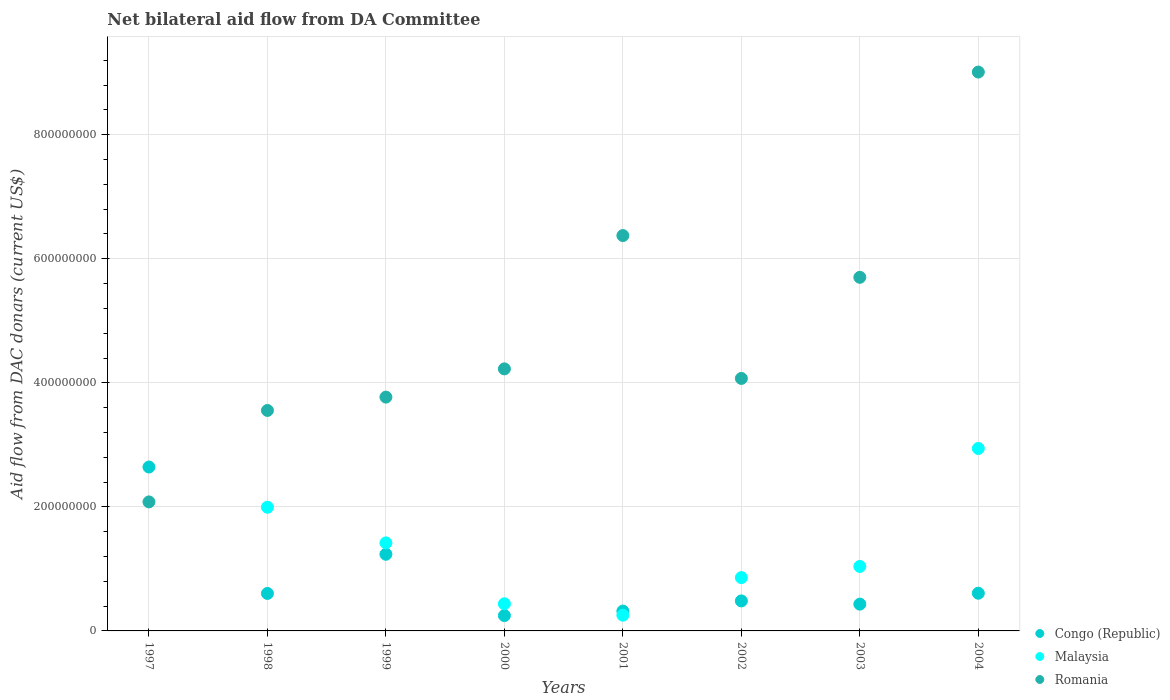How many different coloured dotlines are there?
Keep it short and to the point. 3. What is the aid flow in in Romania in 1998?
Keep it short and to the point. 3.55e+08. Across all years, what is the maximum aid flow in in Romania?
Provide a short and direct response. 9.01e+08. Across all years, what is the minimum aid flow in in Romania?
Provide a short and direct response. 2.08e+08. In which year was the aid flow in in Congo (Republic) maximum?
Make the answer very short. 1997. What is the total aid flow in in Congo (Republic) in the graph?
Offer a terse response. 6.57e+08. What is the difference between the aid flow in in Congo (Republic) in 2001 and that in 2003?
Keep it short and to the point. -1.12e+07. What is the difference between the aid flow in in Malaysia in 2002 and the aid flow in in Romania in 2003?
Your answer should be compact. -4.84e+08. What is the average aid flow in in Congo (Republic) per year?
Provide a succinct answer. 8.22e+07. In the year 2002, what is the difference between the aid flow in in Congo (Republic) and aid flow in in Romania?
Your response must be concise. -3.59e+08. What is the ratio of the aid flow in in Congo (Republic) in 1999 to that in 2003?
Make the answer very short. 2.86. Is the aid flow in in Romania in 2000 less than that in 2001?
Your answer should be very brief. Yes. What is the difference between the highest and the second highest aid flow in in Malaysia?
Your response must be concise. 9.47e+07. What is the difference between the highest and the lowest aid flow in in Malaysia?
Provide a succinct answer. 2.94e+08. In how many years, is the aid flow in in Malaysia greater than the average aid flow in in Malaysia taken over all years?
Your answer should be very brief. 3. Does the aid flow in in Malaysia monotonically increase over the years?
Your response must be concise. No. Is the aid flow in in Malaysia strictly greater than the aid flow in in Romania over the years?
Your answer should be compact. No. How many dotlines are there?
Provide a succinct answer. 3. What is the difference between two consecutive major ticks on the Y-axis?
Offer a very short reply. 2.00e+08. What is the title of the graph?
Offer a very short reply. Net bilateral aid flow from DA Committee. What is the label or title of the X-axis?
Your answer should be very brief. Years. What is the label or title of the Y-axis?
Provide a succinct answer. Aid flow from DAC donars (current US$). What is the Aid flow from DAC donars (current US$) in Congo (Republic) in 1997?
Your response must be concise. 2.64e+08. What is the Aid flow from DAC donars (current US$) of Romania in 1997?
Provide a short and direct response. 2.08e+08. What is the Aid flow from DAC donars (current US$) of Congo (Republic) in 1998?
Give a very brief answer. 6.04e+07. What is the Aid flow from DAC donars (current US$) in Malaysia in 1998?
Your answer should be very brief. 1.99e+08. What is the Aid flow from DAC donars (current US$) of Romania in 1998?
Your answer should be compact. 3.55e+08. What is the Aid flow from DAC donars (current US$) of Congo (Republic) in 1999?
Keep it short and to the point. 1.24e+08. What is the Aid flow from DAC donars (current US$) of Malaysia in 1999?
Your answer should be very brief. 1.42e+08. What is the Aid flow from DAC donars (current US$) in Romania in 1999?
Your answer should be compact. 3.77e+08. What is the Aid flow from DAC donars (current US$) in Congo (Republic) in 2000?
Give a very brief answer. 2.48e+07. What is the Aid flow from DAC donars (current US$) of Malaysia in 2000?
Give a very brief answer. 4.37e+07. What is the Aid flow from DAC donars (current US$) of Romania in 2000?
Your answer should be compact. 4.22e+08. What is the Aid flow from DAC donars (current US$) of Congo (Republic) in 2001?
Keep it short and to the point. 3.20e+07. What is the Aid flow from DAC donars (current US$) in Malaysia in 2001?
Provide a succinct answer. 2.54e+07. What is the Aid flow from DAC donars (current US$) of Romania in 2001?
Give a very brief answer. 6.37e+08. What is the Aid flow from DAC donars (current US$) in Congo (Republic) in 2002?
Your response must be concise. 4.84e+07. What is the Aid flow from DAC donars (current US$) of Malaysia in 2002?
Offer a very short reply. 8.60e+07. What is the Aid flow from DAC donars (current US$) in Romania in 2002?
Provide a short and direct response. 4.07e+08. What is the Aid flow from DAC donars (current US$) of Congo (Republic) in 2003?
Provide a short and direct response. 4.32e+07. What is the Aid flow from DAC donars (current US$) in Malaysia in 2003?
Provide a short and direct response. 1.04e+08. What is the Aid flow from DAC donars (current US$) of Romania in 2003?
Keep it short and to the point. 5.70e+08. What is the Aid flow from DAC donars (current US$) in Congo (Republic) in 2004?
Your answer should be compact. 6.08e+07. What is the Aid flow from DAC donars (current US$) of Malaysia in 2004?
Give a very brief answer. 2.94e+08. What is the Aid flow from DAC donars (current US$) of Romania in 2004?
Keep it short and to the point. 9.01e+08. Across all years, what is the maximum Aid flow from DAC donars (current US$) of Congo (Republic)?
Your answer should be compact. 2.64e+08. Across all years, what is the maximum Aid flow from DAC donars (current US$) of Malaysia?
Your answer should be very brief. 2.94e+08. Across all years, what is the maximum Aid flow from DAC donars (current US$) in Romania?
Ensure brevity in your answer.  9.01e+08. Across all years, what is the minimum Aid flow from DAC donars (current US$) of Congo (Republic)?
Provide a succinct answer. 2.48e+07. Across all years, what is the minimum Aid flow from DAC donars (current US$) in Romania?
Your response must be concise. 2.08e+08. What is the total Aid flow from DAC donars (current US$) of Congo (Republic) in the graph?
Your answer should be compact. 6.57e+08. What is the total Aid flow from DAC donars (current US$) of Malaysia in the graph?
Give a very brief answer. 8.95e+08. What is the total Aid flow from DAC donars (current US$) of Romania in the graph?
Ensure brevity in your answer.  3.88e+09. What is the difference between the Aid flow from DAC donars (current US$) of Congo (Republic) in 1997 and that in 1998?
Keep it short and to the point. 2.04e+08. What is the difference between the Aid flow from DAC donars (current US$) in Romania in 1997 and that in 1998?
Make the answer very short. -1.47e+08. What is the difference between the Aid flow from DAC donars (current US$) of Congo (Republic) in 1997 and that in 1999?
Keep it short and to the point. 1.41e+08. What is the difference between the Aid flow from DAC donars (current US$) in Romania in 1997 and that in 1999?
Provide a succinct answer. -1.69e+08. What is the difference between the Aid flow from DAC donars (current US$) of Congo (Republic) in 1997 and that in 2000?
Your answer should be very brief. 2.39e+08. What is the difference between the Aid flow from DAC donars (current US$) in Romania in 1997 and that in 2000?
Keep it short and to the point. -2.14e+08. What is the difference between the Aid flow from DAC donars (current US$) in Congo (Republic) in 1997 and that in 2001?
Provide a succinct answer. 2.32e+08. What is the difference between the Aid flow from DAC donars (current US$) of Romania in 1997 and that in 2001?
Provide a succinct answer. -4.29e+08. What is the difference between the Aid flow from DAC donars (current US$) of Congo (Republic) in 1997 and that in 2002?
Offer a very short reply. 2.16e+08. What is the difference between the Aid flow from DAC donars (current US$) in Romania in 1997 and that in 2002?
Provide a short and direct response. -1.99e+08. What is the difference between the Aid flow from DAC donars (current US$) of Congo (Republic) in 1997 and that in 2003?
Provide a succinct answer. 2.21e+08. What is the difference between the Aid flow from DAC donars (current US$) in Romania in 1997 and that in 2003?
Provide a succinct answer. -3.62e+08. What is the difference between the Aid flow from DAC donars (current US$) in Congo (Republic) in 1997 and that in 2004?
Your answer should be compact. 2.03e+08. What is the difference between the Aid flow from DAC donars (current US$) in Romania in 1997 and that in 2004?
Make the answer very short. -6.93e+08. What is the difference between the Aid flow from DAC donars (current US$) of Congo (Republic) in 1998 and that in 1999?
Your response must be concise. -6.32e+07. What is the difference between the Aid flow from DAC donars (current US$) in Malaysia in 1998 and that in 1999?
Provide a short and direct response. 5.75e+07. What is the difference between the Aid flow from DAC donars (current US$) in Romania in 1998 and that in 1999?
Keep it short and to the point. -2.15e+07. What is the difference between the Aid flow from DAC donars (current US$) of Congo (Republic) in 1998 and that in 2000?
Provide a short and direct response. 3.56e+07. What is the difference between the Aid flow from DAC donars (current US$) in Malaysia in 1998 and that in 2000?
Keep it short and to the point. 1.56e+08. What is the difference between the Aid flow from DAC donars (current US$) of Romania in 1998 and that in 2000?
Offer a terse response. -6.70e+07. What is the difference between the Aid flow from DAC donars (current US$) of Congo (Republic) in 1998 and that in 2001?
Give a very brief answer. 2.84e+07. What is the difference between the Aid flow from DAC donars (current US$) of Malaysia in 1998 and that in 2001?
Provide a succinct answer. 1.74e+08. What is the difference between the Aid flow from DAC donars (current US$) of Romania in 1998 and that in 2001?
Your response must be concise. -2.82e+08. What is the difference between the Aid flow from DAC donars (current US$) in Congo (Republic) in 1998 and that in 2002?
Provide a succinct answer. 1.21e+07. What is the difference between the Aid flow from DAC donars (current US$) in Malaysia in 1998 and that in 2002?
Your answer should be very brief. 1.13e+08. What is the difference between the Aid flow from DAC donars (current US$) of Romania in 1998 and that in 2002?
Provide a short and direct response. -5.16e+07. What is the difference between the Aid flow from DAC donars (current US$) in Congo (Republic) in 1998 and that in 2003?
Your answer should be compact. 1.72e+07. What is the difference between the Aid flow from DAC donars (current US$) of Malaysia in 1998 and that in 2003?
Provide a succinct answer. 9.55e+07. What is the difference between the Aid flow from DAC donars (current US$) of Romania in 1998 and that in 2003?
Your answer should be compact. -2.15e+08. What is the difference between the Aid flow from DAC donars (current US$) in Congo (Republic) in 1998 and that in 2004?
Ensure brevity in your answer.  -3.70e+05. What is the difference between the Aid flow from DAC donars (current US$) in Malaysia in 1998 and that in 2004?
Your answer should be very brief. -9.47e+07. What is the difference between the Aid flow from DAC donars (current US$) of Romania in 1998 and that in 2004?
Your response must be concise. -5.46e+08. What is the difference between the Aid flow from DAC donars (current US$) of Congo (Republic) in 1999 and that in 2000?
Your response must be concise. 9.88e+07. What is the difference between the Aid flow from DAC donars (current US$) of Malaysia in 1999 and that in 2000?
Provide a succinct answer. 9.82e+07. What is the difference between the Aid flow from DAC donars (current US$) of Romania in 1999 and that in 2000?
Provide a succinct answer. -4.55e+07. What is the difference between the Aid flow from DAC donars (current US$) in Congo (Republic) in 1999 and that in 2001?
Keep it short and to the point. 9.16e+07. What is the difference between the Aid flow from DAC donars (current US$) in Malaysia in 1999 and that in 2001?
Give a very brief answer. 1.17e+08. What is the difference between the Aid flow from DAC donars (current US$) of Romania in 1999 and that in 2001?
Ensure brevity in your answer.  -2.60e+08. What is the difference between the Aid flow from DAC donars (current US$) in Congo (Republic) in 1999 and that in 2002?
Your answer should be compact. 7.52e+07. What is the difference between the Aid flow from DAC donars (current US$) of Malaysia in 1999 and that in 2002?
Your response must be concise. 5.59e+07. What is the difference between the Aid flow from DAC donars (current US$) in Romania in 1999 and that in 2002?
Offer a very short reply. -3.01e+07. What is the difference between the Aid flow from DAC donars (current US$) of Congo (Republic) in 1999 and that in 2003?
Your answer should be compact. 8.04e+07. What is the difference between the Aid flow from DAC donars (current US$) of Malaysia in 1999 and that in 2003?
Make the answer very short. 3.79e+07. What is the difference between the Aid flow from DAC donars (current US$) of Romania in 1999 and that in 2003?
Make the answer very short. -1.93e+08. What is the difference between the Aid flow from DAC donars (current US$) in Congo (Republic) in 1999 and that in 2004?
Your answer should be compact. 6.28e+07. What is the difference between the Aid flow from DAC donars (current US$) in Malaysia in 1999 and that in 2004?
Offer a very short reply. -1.52e+08. What is the difference between the Aid flow from DAC donars (current US$) of Romania in 1999 and that in 2004?
Provide a short and direct response. -5.24e+08. What is the difference between the Aid flow from DAC donars (current US$) of Congo (Republic) in 2000 and that in 2001?
Provide a short and direct response. -7.24e+06. What is the difference between the Aid flow from DAC donars (current US$) in Malaysia in 2000 and that in 2001?
Offer a terse response. 1.84e+07. What is the difference between the Aid flow from DAC donars (current US$) in Romania in 2000 and that in 2001?
Ensure brevity in your answer.  -2.15e+08. What is the difference between the Aid flow from DAC donars (current US$) of Congo (Republic) in 2000 and that in 2002?
Your response must be concise. -2.36e+07. What is the difference between the Aid flow from DAC donars (current US$) of Malaysia in 2000 and that in 2002?
Keep it short and to the point. -4.22e+07. What is the difference between the Aid flow from DAC donars (current US$) of Romania in 2000 and that in 2002?
Provide a short and direct response. 1.54e+07. What is the difference between the Aid flow from DAC donars (current US$) of Congo (Republic) in 2000 and that in 2003?
Your answer should be compact. -1.84e+07. What is the difference between the Aid flow from DAC donars (current US$) of Malaysia in 2000 and that in 2003?
Make the answer very short. -6.02e+07. What is the difference between the Aid flow from DAC donars (current US$) of Romania in 2000 and that in 2003?
Provide a short and direct response. -1.48e+08. What is the difference between the Aid flow from DAC donars (current US$) of Congo (Republic) in 2000 and that in 2004?
Provide a short and direct response. -3.60e+07. What is the difference between the Aid flow from DAC donars (current US$) in Malaysia in 2000 and that in 2004?
Offer a terse response. -2.50e+08. What is the difference between the Aid flow from DAC donars (current US$) of Romania in 2000 and that in 2004?
Ensure brevity in your answer.  -4.79e+08. What is the difference between the Aid flow from DAC donars (current US$) of Congo (Republic) in 2001 and that in 2002?
Your answer should be compact. -1.64e+07. What is the difference between the Aid flow from DAC donars (current US$) in Malaysia in 2001 and that in 2002?
Your answer should be compact. -6.06e+07. What is the difference between the Aid flow from DAC donars (current US$) in Romania in 2001 and that in 2002?
Ensure brevity in your answer.  2.30e+08. What is the difference between the Aid flow from DAC donars (current US$) of Congo (Republic) in 2001 and that in 2003?
Keep it short and to the point. -1.12e+07. What is the difference between the Aid flow from DAC donars (current US$) of Malaysia in 2001 and that in 2003?
Keep it short and to the point. -7.86e+07. What is the difference between the Aid flow from DAC donars (current US$) of Romania in 2001 and that in 2003?
Provide a short and direct response. 6.73e+07. What is the difference between the Aid flow from DAC donars (current US$) of Congo (Republic) in 2001 and that in 2004?
Your response must be concise. -2.88e+07. What is the difference between the Aid flow from DAC donars (current US$) of Malaysia in 2001 and that in 2004?
Give a very brief answer. -2.69e+08. What is the difference between the Aid flow from DAC donars (current US$) of Romania in 2001 and that in 2004?
Offer a terse response. -2.64e+08. What is the difference between the Aid flow from DAC donars (current US$) in Congo (Republic) in 2002 and that in 2003?
Your answer should be very brief. 5.19e+06. What is the difference between the Aid flow from DAC donars (current US$) in Malaysia in 2002 and that in 2003?
Offer a terse response. -1.80e+07. What is the difference between the Aid flow from DAC donars (current US$) of Romania in 2002 and that in 2003?
Offer a very short reply. -1.63e+08. What is the difference between the Aid flow from DAC donars (current US$) in Congo (Republic) in 2002 and that in 2004?
Your response must be concise. -1.24e+07. What is the difference between the Aid flow from DAC donars (current US$) in Malaysia in 2002 and that in 2004?
Provide a succinct answer. -2.08e+08. What is the difference between the Aid flow from DAC donars (current US$) in Romania in 2002 and that in 2004?
Give a very brief answer. -4.94e+08. What is the difference between the Aid flow from DAC donars (current US$) in Congo (Republic) in 2003 and that in 2004?
Your answer should be very brief. -1.76e+07. What is the difference between the Aid flow from DAC donars (current US$) in Malaysia in 2003 and that in 2004?
Your response must be concise. -1.90e+08. What is the difference between the Aid flow from DAC donars (current US$) in Romania in 2003 and that in 2004?
Give a very brief answer. -3.31e+08. What is the difference between the Aid flow from DAC donars (current US$) in Congo (Republic) in 1997 and the Aid flow from DAC donars (current US$) in Malaysia in 1998?
Make the answer very short. 6.48e+07. What is the difference between the Aid flow from DAC donars (current US$) of Congo (Republic) in 1997 and the Aid flow from DAC donars (current US$) of Romania in 1998?
Keep it short and to the point. -9.12e+07. What is the difference between the Aid flow from DAC donars (current US$) in Congo (Republic) in 1997 and the Aid flow from DAC donars (current US$) in Malaysia in 1999?
Offer a very short reply. 1.22e+08. What is the difference between the Aid flow from DAC donars (current US$) in Congo (Republic) in 1997 and the Aid flow from DAC donars (current US$) in Romania in 1999?
Provide a succinct answer. -1.13e+08. What is the difference between the Aid flow from DAC donars (current US$) in Congo (Republic) in 1997 and the Aid flow from DAC donars (current US$) in Malaysia in 2000?
Your answer should be very brief. 2.20e+08. What is the difference between the Aid flow from DAC donars (current US$) in Congo (Republic) in 1997 and the Aid flow from DAC donars (current US$) in Romania in 2000?
Your response must be concise. -1.58e+08. What is the difference between the Aid flow from DAC donars (current US$) in Congo (Republic) in 1997 and the Aid flow from DAC donars (current US$) in Malaysia in 2001?
Provide a succinct answer. 2.39e+08. What is the difference between the Aid flow from DAC donars (current US$) of Congo (Republic) in 1997 and the Aid flow from DAC donars (current US$) of Romania in 2001?
Give a very brief answer. -3.73e+08. What is the difference between the Aid flow from DAC donars (current US$) in Congo (Republic) in 1997 and the Aid flow from DAC donars (current US$) in Malaysia in 2002?
Provide a short and direct response. 1.78e+08. What is the difference between the Aid flow from DAC donars (current US$) of Congo (Republic) in 1997 and the Aid flow from DAC donars (current US$) of Romania in 2002?
Keep it short and to the point. -1.43e+08. What is the difference between the Aid flow from DAC donars (current US$) in Congo (Republic) in 1997 and the Aid flow from DAC donars (current US$) in Malaysia in 2003?
Your answer should be very brief. 1.60e+08. What is the difference between the Aid flow from DAC donars (current US$) of Congo (Republic) in 1997 and the Aid flow from DAC donars (current US$) of Romania in 2003?
Provide a succinct answer. -3.06e+08. What is the difference between the Aid flow from DAC donars (current US$) in Congo (Republic) in 1997 and the Aid flow from DAC donars (current US$) in Malaysia in 2004?
Give a very brief answer. -2.99e+07. What is the difference between the Aid flow from DAC donars (current US$) in Congo (Republic) in 1997 and the Aid flow from DAC donars (current US$) in Romania in 2004?
Ensure brevity in your answer.  -6.37e+08. What is the difference between the Aid flow from DAC donars (current US$) in Congo (Republic) in 1998 and the Aid flow from DAC donars (current US$) in Malaysia in 1999?
Your answer should be compact. -8.15e+07. What is the difference between the Aid flow from DAC donars (current US$) of Congo (Republic) in 1998 and the Aid flow from DAC donars (current US$) of Romania in 1999?
Offer a terse response. -3.17e+08. What is the difference between the Aid flow from DAC donars (current US$) of Malaysia in 1998 and the Aid flow from DAC donars (current US$) of Romania in 1999?
Offer a very short reply. -1.78e+08. What is the difference between the Aid flow from DAC donars (current US$) in Congo (Republic) in 1998 and the Aid flow from DAC donars (current US$) in Malaysia in 2000?
Give a very brief answer. 1.67e+07. What is the difference between the Aid flow from DAC donars (current US$) of Congo (Republic) in 1998 and the Aid flow from DAC donars (current US$) of Romania in 2000?
Give a very brief answer. -3.62e+08. What is the difference between the Aid flow from DAC donars (current US$) of Malaysia in 1998 and the Aid flow from DAC donars (current US$) of Romania in 2000?
Offer a terse response. -2.23e+08. What is the difference between the Aid flow from DAC donars (current US$) in Congo (Republic) in 1998 and the Aid flow from DAC donars (current US$) in Malaysia in 2001?
Your response must be concise. 3.50e+07. What is the difference between the Aid flow from DAC donars (current US$) of Congo (Republic) in 1998 and the Aid flow from DAC donars (current US$) of Romania in 2001?
Your response must be concise. -5.77e+08. What is the difference between the Aid flow from DAC donars (current US$) of Malaysia in 1998 and the Aid flow from DAC donars (current US$) of Romania in 2001?
Offer a very short reply. -4.38e+08. What is the difference between the Aid flow from DAC donars (current US$) of Congo (Republic) in 1998 and the Aid flow from DAC donars (current US$) of Malaysia in 2002?
Keep it short and to the point. -2.56e+07. What is the difference between the Aid flow from DAC donars (current US$) in Congo (Republic) in 1998 and the Aid flow from DAC donars (current US$) in Romania in 2002?
Offer a very short reply. -3.47e+08. What is the difference between the Aid flow from DAC donars (current US$) in Malaysia in 1998 and the Aid flow from DAC donars (current US$) in Romania in 2002?
Your answer should be very brief. -2.08e+08. What is the difference between the Aid flow from DAC donars (current US$) of Congo (Republic) in 1998 and the Aid flow from DAC donars (current US$) of Malaysia in 2003?
Ensure brevity in your answer.  -4.36e+07. What is the difference between the Aid flow from DAC donars (current US$) of Congo (Republic) in 1998 and the Aid flow from DAC donars (current US$) of Romania in 2003?
Provide a short and direct response. -5.10e+08. What is the difference between the Aid flow from DAC donars (current US$) in Malaysia in 1998 and the Aid flow from DAC donars (current US$) in Romania in 2003?
Your answer should be very brief. -3.71e+08. What is the difference between the Aid flow from DAC donars (current US$) of Congo (Republic) in 1998 and the Aid flow from DAC donars (current US$) of Malaysia in 2004?
Your answer should be compact. -2.34e+08. What is the difference between the Aid flow from DAC donars (current US$) of Congo (Republic) in 1998 and the Aid flow from DAC donars (current US$) of Romania in 2004?
Make the answer very short. -8.41e+08. What is the difference between the Aid flow from DAC donars (current US$) of Malaysia in 1998 and the Aid flow from DAC donars (current US$) of Romania in 2004?
Ensure brevity in your answer.  -7.02e+08. What is the difference between the Aid flow from DAC donars (current US$) in Congo (Republic) in 1999 and the Aid flow from DAC donars (current US$) in Malaysia in 2000?
Ensure brevity in your answer.  7.98e+07. What is the difference between the Aid flow from DAC donars (current US$) in Congo (Republic) in 1999 and the Aid flow from DAC donars (current US$) in Romania in 2000?
Your answer should be compact. -2.99e+08. What is the difference between the Aid flow from DAC donars (current US$) of Malaysia in 1999 and the Aid flow from DAC donars (current US$) of Romania in 2000?
Offer a terse response. -2.81e+08. What is the difference between the Aid flow from DAC donars (current US$) in Congo (Republic) in 1999 and the Aid flow from DAC donars (current US$) in Malaysia in 2001?
Offer a very short reply. 9.82e+07. What is the difference between the Aid flow from DAC donars (current US$) in Congo (Republic) in 1999 and the Aid flow from DAC donars (current US$) in Romania in 2001?
Keep it short and to the point. -5.14e+08. What is the difference between the Aid flow from DAC donars (current US$) of Malaysia in 1999 and the Aid flow from DAC donars (current US$) of Romania in 2001?
Provide a succinct answer. -4.96e+08. What is the difference between the Aid flow from DAC donars (current US$) in Congo (Republic) in 1999 and the Aid flow from DAC donars (current US$) in Malaysia in 2002?
Provide a short and direct response. 3.76e+07. What is the difference between the Aid flow from DAC donars (current US$) of Congo (Republic) in 1999 and the Aid flow from DAC donars (current US$) of Romania in 2002?
Offer a very short reply. -2.84e+08. What is the difference between the Aid flow from DAC donars (current US$) in Malaysia in 1999 and the Aid flow from DAC donars (current US$) in Romania in 2002?
Offer a very short reply. -2.65e+08. What is the difference between the Aid flow from DAC donars (current US$) in Congo (Republic) in 1999 and the Aid flow from DAC donars (current US$) in Malaysia in 2003?
Provide a succinct answer. 1.96e+07. What is the difference between the Aid flow from DAC donars (current US$) in Congo (Republic) in 1999 and the Aid flow from DAC donars (current US$) in Romania in 2003?
Give a very brief answer. -4.47e+08. What is the difference between the Aid flow from DAC donars (current US$) in Malaysia in 1999 and the Aid flow from DAC donars (current US$) in Romania in 2003?
Give a very brief answer. -4.28e+08. What is the difference between the Aid flow from DAC donars (current US$) of Congo (Republic) in 1999 and the Aid flow from DAC donars (current US$) of Malaysia in 2004?
Your answer should be very brief. -1.71e+08. What is the difference between the Aid flow from DAC donars (current US$) in Congo (Republic) in 1999 and the Aid flow from DAC donars (current US$) in Romania in 2004?
Ensure brevity in your answer.  -7.77e+08. What is the difference between the Aid flow from DAC donars (current US$) of Malaysia in 1999 and the Aid flow from DAC donars (current US$) of Romania in 2004?
Provide a succinct answer. -7.59e+08. What is the difference between the Aid flow from DAC donars (current US$) in Congo (Republic) in 2000 and the Aid flow from DAC donars (current US$) in Malaysia in 2001?
Provide a short and direct response. -6.30e+05. What is the difference between the Aid flow from DAC donars (current US$) of Congo (Republic) in 2000 and the Aid flow from DAC donars (current US$) of Romania in 2001?
Your response must be concise. -6.13e+08. What is the difference between the Aid flow from DAC donars (current US$) of Malaysia in 2000 and the Aid flow from DAC donars (current US$) of Romania in 2001?
Your response must be concise. -5.94e+08. What is the difference between the Aid flow from DAC donars (current US$) of Congo (Republic) in 2000 and the Aid flow from DAC donars (current US$) of Malaysia in 2002?
Ensure brevity in your answer.  -6.12e+07. What is the difference between the Aid flow from DAC donars (current US$) in Congo (Republic) in 2000 and the Aid flow from DAC donars (current US$) in Romania in 2002?
Provide a succinct answer. -3.82e+08. What is the difference between the Aid flow from DAC donars (current US$) in Malaysia in 2000 and the Aid flow from DAC donars (current US$) in Romania in 2002?
Your response must be concise. -3.63e+08. What is the difference between the Aid flow from DAC donars (current US$) of Congo (Republic) in 2000 and the Aid flow from DAC donars (current US$) of Malaysia in 2003?
Your answer should be very brief. -7.92e+07. What is the difference between the Aid flow from DAC donars (current US$) of Congo (Republic) in 2000 and the Aid flow from DAC donars (current US$) of Romania in 2003?
Your answer should be compact. -5.45e+08. What is the difference between the Aid flow from DAC donars (current US$) of Malaysia in 2000 and the Aid flow from DAC donars (current US$) of Romania in 2003?
Your answer should be very brief. -5.26e+08. What is the difference between the Aid flow from DAC donars (current US$) in Congo (Republic) in 2000 and the Aid flow from DAC donars (current US$) in Malaysia in 2004?
Give a very brief answer. -2.69e+08. What is the difference between the Aid flow from DAC donars (current US$) in Congo (Republic) in 2000 and the Aid flow from DAC donars (current US$) in Romania in 2004?
Ensure brevity in your answer.  -8.76e+08. What is the difference between the Aid flow from DAC donars (current US$) in Malaysia in 2000 and the Aid flow from DAC donars (current US$) in Romania in 2004?
Offer a terse response. -8.57e+08. What is the difference between the Aid flow from DAC donars (current US$) in Congo (Republic) in 2001 and the Aid flow from DAC donars (current US$) in Malaysia in 2002?
Your answer should be very brief. -5.40e+07. What is the difference between the Aid flow from DAC donars (current US$) of Congo (Republic) in 2001 and the Aid flow from DAC donars (current US$) of Romania in 2002?
Your response must be concise. -3.75e+08. What is the difference between the Aid flow from DAC donars (current US$) of Malaysia in 2001 and the Aid flow from DAC donars (current US$) of Romania in 2002?
Make the answer very short. -3.82e+08. What is the difference between the Aid flow from DAC donars (current US$) of Congo (Republic) in 2001 and the Aid flow from DAC donars (current US$) of Malaysia in 2003?
Ensure brevity in your answer.  -7.20e+07. What is the difference between the Aid flow from DAC donars (current US$) of Congo (Republic) in 2001 and the Aid flow from DAC donars (current US$) of Romania in 2003?
Keep it short and to the point. -5.38e+08. What is the difference between the Aid flow from DAC donars (current US$) in Malaysia in 2001 and the Aid flow from DAC donars (current US$) in Romania in 2003?
Your response must be concise. -5.45e+08. What is the difference between the Aid flow from DAC donars (current US$) in Congo (Republic) in 2001 and the Aid flow from DAC donars (current US$) in Malaysia in 2004?
Your answer should be compact. -2.62e+08. What is the difference between the Aid flow from DAC donars (current US$) of Congo (Republic) in 2001 and the Aid flow from DAC donars (current US$) of Romania in 2004?
Make the answer very short. -8.69e+08. What is the difference between the Aid flow from DAC donars (current US$) of Malaysia in 2001 and the Aid flow from DAC donars (current US$) of Romania in 2004?
Give a very brief answer. -8.76e+08. What is the difference between the Aid flow from DAC donars (current US$) in Congo (Republic) in 2002 and the Aid flow from DAC donars (current US$) in Malaysia in 2003?
Provide a succinct answer. -5.56e+07. What is the difference between the Aid flow from DAC donars (current US$) of Congo (Republic) in 2002 and the Aid flow from DAC donars (current US$) of Romania in 2003?
Your answer should be compact. -5.22e+08. What is the difference between the Aid flow from DAC donars (current US$) of Malaysia in 2002 and the Aid flow from DAC donars (current US$) of Romania in 2003?
Offer a terse response. -4.84e+08. What is the difference between the Aid flow from DAC donars (current US$) in Congo (Republic) in 2002 and the Aid flow from DAC donars (current US$) in Malaysia in 2004?
Your answer should be very brief. -2.46e+08. What is the difference between the Aid flow from DAC donars (current US$) of Congo (Republic) in 2002 and the Aid flow from DAC donars (current US$) of Romania in 2004?
Ensure brevity in your answer.  -8.53e+08. What is the difference between the Aid flow from DAC donars (current US$) of Malaysia in 2002 and the Aid flow from DAC donars (current US$) of Romania in 2004?
Offer a very short reply. -8.15e+08. What is the difference between the Aid flow from DAC donars (current US$) in Congo (Republic) in 2003 and the Aid flow from DAC donars (current US$) in Malaysia in 2004?
Ensure brevity in your answer.  -2.51e+08. What is the difference between the Aid flow from DAC donars (current US$) of Congo (Republic) in 2003 and the Aid flow from DAC donars (current US$) of Romania in 2004?
Your response must be concise. -8.58e+08. What is the difference between the Aid flow from DAC donars (current US$) of Malaysia in 2003 and the Aid flow from DAC donars (current US$) of Romania in 2004?
Provide a succinct answer. -7.97e+08. What is the average Aid flow from DAC donars (current US$) of Congo (Republic) per year?
Make the answer very short. 8.22e+07. What is the average Aid flow from DAC donars (current US$) in Malaysia per year?
Your response must be concise. 1.12e+08. What is the average Aid flow from DAC donars (current US$) in Romania per year?
Provide a succinct answer. 4.85e+08. In the year 1997, what is the difference between the Aid flow from DAC donars (current US$) of Congo (Republic) and Aid flow from DAC donars (current US$) of Romania?
Make the answer very short. 5.62e+07. In the year 1998, what is the difference between the Aid flow from DAC donars (current US$) of Congo (Republic) and Aid flow from DAC donars (current US$) of Malaysia?
Offer a terse response. -1.39e+08. In the year 1998, what is the difference between the Aid flow from DAC donars (current US$) of Congo (Republic) and Aid flow from DAC donars (current US$) of Romania?
Your answer should be very brief. -2.95e+08. In the year 1998, what is the difference between the Aid flow from DAC donars (current US$) of Malaysia and Aid flow from DAC donars (current US$) of Romania?
Your answer should be compact. -1.56e+08. In the year 1999, what is the difference between the Aid flow from DAC donars (current US$) in Congo (Republic) and Aid flow from DAC donars (current US$) in Malaysia?
Make the answer very short. -1.83e+07. In the year 1999, what is the difference between the Aid flow from DAC donars (current US$) in Congo (Republic) and Aid flow from DAC donars (current US$) in Romania?
Offer a very short reply. -2.53e+08. In the year 1999, what is the difference between the Aid flow from DAC donars (current US$) of Malaysia and Aid flow from DAC donars (current US$) of Romania?
Your response must be concise. -2.35e+08. In the year 2000, what is the difference between the Aid flow from DAC donars (current US$) in Congo (Republic) and Aid flow from DAC donars (current US$) in Malaysia?
Keep it short and to the point. -1.90e+07. In the year 2000, what is the difference between the Aid flow from DAC donars (current US$) of Congo (Republic) and Aid flow from DAC donars (current US$) of Romania?
Make the answer very short. -3.98e+08. In the year 2000, what is the difference between the Aid flow from DAC donars (current US$) in Malaysia and Aid flow from DAC donars (current US$) in Romania?
Ensure brevity in your answer.  -3.79e+08. In the year 2001, what is the difference between the Aid flow from DAC donars (current US$) in Congo (Republic) and Aid flow from DAC donars (current US$) in Malaysia?
Provide a succinct answer. 6.61e+06. In the year 2001, what is the difference between the Aid flow from DAC donars (current US$) of Congo (Republic) and Aid flow from DAC donars (current US$) of Romania?
Offer a very short reply. -6.05e+08. In the year 2001, what is the difference between the Aid flow from DAC donars (current US$) in Malaysia and Aid flow from DAC donars (current US$) in Romania?
Make the answer very short. -6.12e+08. In the year 2002, what is the difference between the Aid flow from DAC donars (current US$) in Congo (Republic) and Aid flow from DAC donars (current US$) in Malaysia?
Keep it short and to the point. -3.76e+07. In the year 2002, what is the difference between the Aid flow from DAC donars (current US$) of Congo (Republic) and Aid flow from DAC donars (current US$) of Romania?
Provide a short and direct response. -3.59e+08. In the year 2002, what is the difference between the Aid flow from DAC donars (current US$) of Malaysia and Aid flow from DAC donars (current US$) of Romania?
Offer a terse response. -3.21e+08. In the year 2003, what is the difference between the Aid flow from DAC donars (current US$) of Congo (Republic) and Aid flow from DAC donars (current US$) of Malaysia?
Ensure brevity in your answer.  -6.08e+07. In the year 2003, what is the difference between the Aid flow from DAC donars (current US$) of Congo (Republic) and Aid flow from DAC donars (current US$) of Romania?
Your response must be concise. -5.27e+08. In the year 2003, what is the difference between the Aid flow from DAC donars (current US$) of Malaysia and Aid flow from DAC donars (current US$) of Romania?
Provide a succinct answer. -4.66e+08. In the year 2004, what is the difference between the Aid flow from DAC donars (current US$) of Congo (Republic) and Aid flow from DAC donars (current US$) of Malaysia?
Give a very brief answer. -2.33e+08. In the year 2004, what is the difference between the Aid flow from DAC donars (current US$) of Congo (Republic) and Aid flow from DAC donars (current US$) of Romania?
Provide a succinct answer. -8.40e+08. In the year 2004, what is the difference between the Aid flow from DAC donars (current US$) of Malaysia and Aid flow from DAC donars (current US$) of Romania?
Your response must be concise. -6.07e+08. What is the ratio of the Aid flow from DAC donars (current US$) of Congo (Republic) in 1997 to that in 1998?
Your answer should be very brief. 4.37. What is the ratio of the Aid flow from DAC donars (current US$) of Romania in 1997 to that in 1998?
Your answer should be compact. 0.59. What is the ratio of the Aid flow from DAC donars (current US$) of Congo (Republic) in 1997 to that in 1999?
Give a very brief answer. 2.14. What is the ratio of the Aid flow from DAC donars (current US$) in Romania in 1997 to that in 1999?
Your answer should be very brief. 0.55. What is the ratio of the Aid flow from DAC donars (current US$) of Congo (Republic) in 1997 to that in 2000?
Offer a very short reply. 10.67. What is the ratio of the Aid flow from DAC donars (current US$) of Romania in 1997 to that in 2000?
Keep it short and to the point. 0.49. What is the ratio of the Aid flow from DAC donars (current US$) in Congo (Republic) in 1997 to that in 2001?
Give a very brief answer. 8.26. What is the ratio of the Aid flow from DAC donars (current US$) of Romania in 1997 to that in 2001?
Give a very brief answer. 0.33. What is the ratio of the Aid flow from DAC donars (current US$) in Congo (Republic) in 1997 to that in 2002?
Your answer should be very brief. 5.47. What is the ratio of the Aid flow from DAC donars (current US$) in Romania in 1997 to that in 2002?
Provide a short and direct response. 0.51. What is the ratio of the Aid flow from DAC donars (current US$) in Congo (Republic) in 1997 to that in 2003?
Your answer should be compact. 6.12. What is the ratio of the Aid flow from DAC donars (current US$) in Romania in 1997 to that in 2003?
Your response must be concise. 0.36. What is the ratio of the Aid flow from DAC donars (current US$) of Congo (Republic) in 1997 to that in 2004?
Offer a terse response. 4.35. What is the ratio of the Aid flow from DAC donars (current US$) of Romania in 1997 to that in 2004?
Make the answer very short. 0.23. What is the ratio of the Aid flow from DAC donars (current US$) of Congo (Republic) in 1998 to that in 1999?
Offer a very short reply. 0.49. What is the ratio of the Aid flow from DAC donars (current US$) in Malaysia in 1998 to that in 1999?
Your response must be concise. 1.41. What is the ratio of the Aid flow from DAC donars (current US$) of Romania in 1998 to that in 1999?
Offer a terse response. 0.94. What is the ratio of the Aid flow from DAC donars (current US$) in Congo (Republic) in 1998 to that in 2000?
Make the answer very short. 2.44. What is the ratio of the Aid flow from DAC donars (current US$) in Malaysia in 1998 to that in 2000?
Provide a short and direct response. 4.56. What is the ratio of the Aid flow from DAC donars (current US$) of Romania in 1998 to that in 2000?
Offer a very short reply. 0.84. What is the ratio of the Aid flow from DAC donars (current US$) in Congo (Republic) in 1998 to that in 2001?
Provide a short and direct response. 1.89. What is the ratio of the Aid flow from DAC donars (current US$) in Malaysia in 1998 to that in 2001?
Give a very brief answer. 7.86. What is the ratio of the Aid flow from DAC donars (current US$) of Romania in 1998 to that in 2001?
Give a very brief answer. 0.56. What is the ratio of the Aid flow from DAC donars (current US$) of Congo (Republic) in 1998 to that in 2002?
Provide a succinct answer. 1.25. What is the ratio of the Aid flow from DAC donars (current US$) of Malaysia in 1998 to that in 2002?
Your answer should be compact. 2.32. What is the ratio of the Aid flow from DAC donars (current US$) in Romania in 1998 to that in 2002?
Offer a very short reply. 0.87. What is the ratio of the Aid flow from DAC donars (current US$) in Congo (Republic) in 1998 to that in 2003?
Make the answer very short. 1.4. What is the ratio of the Aid flow from DAC donars (current US$) of Malaysia in 1998 to that in 2003?
Give a very brief answer. 1.92. What is the ratio of the Aid flow from DAC donars (current US$) in Romania in 1998 to that in 2003?
Give a very brief answer. 0.62. What is the ratio of the Aid flow from DAC donars (current US$) of Malaysia in 1998 to that in 2004?
Your response must be concise. 0.68. What is the ratio of the Aid flow from DAC donars (current US$) of Romania in 1998 to that in 2004?
Offer a terse response. 0.39. What is the ratio of the Aid flow from DAC donars (current US$) in Congo (Republic) in 1999 to that in 2000?
Your answer should be very brief. 4.99. What is the ratio of the Aid flow from DAC donars (current US$) of Malaysia in 1999 to that in 2000?
Your response must be concise. 3.24. What is the ratio of the Aid flow from DAC donars (current US$) of Romania in 1999 to that in 2000?
Give a very brief answer. 0.89. What is the ratio of the Aid flow from DAC donars (current US$) in Congo (Republic) in 1999 to that in 2001?
Your answer should be compact. 3.86. What is the ratio of the Aid flow from DAC donars (current US$) of Malaysia in 1999 to that in 2001?
Keep it short and to the point. 5.59. What is the ratio of the Aid flow from DAC donars (current US$) in Romania in 1999 to that in 2001?
Provide a succinct answer. 0.59. What is the ratio of the Aid flow from DAC donars (current US$) in Congo (Republic) in 1999 to that in 2002?
Provide a short and direct response. 2.56. What is the ratio of the Aid flow from DAC donars (current US$) of Malaysia in 1999 to that in 2002?
Offer a very short reply. 1.65. What is the ratio of the Aid flow from DAC donars (current US$) of Romania in 1999 to that in 2002?
Offer a very short reply. 0.93. What is the ratio of the Aid flow from DAC donars (current US$) of Congo (Republic) in 1999 to that in 2003?
Offer a very short reply. 2.86. What is the ratio of the Aid flow from DAC donars (current US$) of Malaysia in 1999 to that in 2003?
Make the answer very short. 1.36. What is the ratio of the Aid flow from DAC donars (current US$) of Romania in 1999 to that in 2003?
Give a very brief answer. 0.66. What is the ratio of the Aid flow from DAC donars (current US$) in Congo (Republic) in 1999 to that in 2004?
Offer a very short reply. 2.03. What is the ratio of the Aid flow from DAC donars (current US$) of Malaysia in 1999 to that in 2004?
Give a very brief answer. 0.48. What is the ratio of the Aid flow from DAC donars (current US$) in Romania in 1999 to that in 2004?
Ensure brevity in your answer.  0.42. What is the ratio of the Aid flow from DAC donars (current US$) of Congo (Republic) in 2000 to that in 2001?
Your response must be concise. 0.77. What is the ratio of the Aid flow from DAC donars (current US$) of Malaysia in 2000 to that in 2001?
Provide a short and direct response. 1.72. What is the ratio of the Aid flow from DAC donars (current US$) in Romania in 2000 to that in 2001?
Offer a very short reply. 0.66. What is the ratio of the Aid flow from DAC donars (current US$) of Congo (Republic) in 2000 to that in 2002?
Your answer should be compact. 0.51. What is the ratio of the Aid flow from DAC donars (current US$) of Malaysia in 2000 to that in 2002?
Ensure brevity in your answer.  0.51. What is the ratio of the Aid flow from DAC donars (current US$) in Romania in 2000 to that in 2002?
Keep it short and to the point. 1.04. What is the ratio of the Aid flow from DAC donars (current US$) of Congo (Republic) in 2000 to that in 2003?
Make the answer very short. 0.57. What is the ratio of the Aid flow from DAC donars (current US$) in Malaysia in 2000 to that in 2003?
Give a very brief answer. 0.42. What is the ratio of the Aid flow from DAC donars (current US$) of Romania in 2000 to that in 2003?
Keep it short and to the point. 0.74. What is the ratio of the Aid flow from DAC donars (current US$) of Congo (Republic) in 2000 to that in 2004?
Your answer should be very brief. 0.41. What is the ratio of the Aid flow from DAC donars (current US$) of Malaysia in 2000 to that in 2004?
Keep it short and to the point. 0.15. What is the ratio of the Aid flow from DAC donars (current US$) in Romania in 2000 to that in 2004?
Offer a very short reply. 0.47. What is the ratio of the Aid flow from DAC donars (current US$) of Congo (Republic) in 2001 to that in 2002?
Your answer should be very brief. 0.66. What is the ratio of the Aid flow from DAC donars (current US$) of Malaysia in 2001 to that in 2002?
Make the answer very short. 0.3. What is the ratio of the Aid flow from DAC donars (current US$) in Romania in 2001 to that in 2002?
Give a very brief answer. 1.57. What is the ratio of the Aid flow from DAC donars (current US$) in Congo (Republic) in 2001 to that in 2003?
Your answer should be compact. 0.74. What is the ratio of the Aid flow from DAC donars (current US$) in Malaysia in 2001 to that in 2003?
Your response must be concise. 0.24. What is the ratio of the Aid flow from DAC donars (current US$) of Romania in 2001 to that in 2003?
Provide a succinct answer. 1.12. What is the ratio of the Aid flow from DAC donars (current US$) of Congo (Republic) in 2001 to that in 2004?
Your response must be concise. 0.53. What is the ratio of the Aid flow from DAC donars (current US$) of Malaysia in 2001 to that in 2004?
Your answer should be very brief. 0.09. What is the ratio of the Aid flow from DAC donars (current US$) in Romania in 2001 to that in 2004?
Keep it short and to the point. 0.71. What is the ratio of the Aid flow from DAC donars (current US$) of Congo (Republic) in 2002 to that in 2003?
Make the answer very short. 1.12. What is the ratio of the Aid flow from DAC donars (current US$) of Malaysia in 2002 to that in 2003?
Keep it short and to the point. 0.83. What is the ratio of the Aid flow from DAC donars (current US$) in Romania in 2002 to that in 2003?
Provide a short and direct response. 0.71. What is the ratio of the Aid flow from DAC donars (current US$) of Congo (Republic) in 2002 to that in 2004?
Your response must be concise. 0.8. What is the ratio of the Aid flow from DAC donars (current US$) of Malaysia in 2002 to that in 2004?
Offer a very short reply. 0.29. What is the ratio of the Aid flow from DAC donars (current US$) in Romania in 2002 to that in 2004?
Offer a terse response. 0.45. What is the ratio of the Aid flow from DAC donars (current US$) in Congo (Republic) in 2003 to that in 2004?
Your response must be concise. 0.71. What is the ratio of the Aid flow from DAC donars (current US$) in Malaysia in 2003 to that in 2004?
Provide a succinct answer. 0.35. What is the ratio of the Aid flow from DAC donars (current US$) in Romania in 2003 to that in 2004?
Your answer should be very brief. 0.63. What is the difference between the highest and the second highest Aid flow from DAC donars (current US$) of Congo (Republic)?
Provide a short and direct response. 1.41e+08. What is the difference between the highest and the second highest Aid flow from DAC donars (current US$) of Malaysia?
Give a very brief answer. 9.47e+07. What is the difference between the highest and the second highest Aid flow from DAC donars (current US$) in Romania?
Offer a terse response. 2.64e+08. What is the difference between the highest and the lowest Aid flow from DAC donars (current US$) in Congo (Republic)?
Your answer should be compact. 2.39e+08. What is the difference between the highest and the lowest Aid flow from DAC donars (current US$) of Malaysia?
Offer a terse response. 2.94e+08. What is the difference between the highest and the lowest Aid flow from DAC donars (current US$) of Romania?
Your response must be concise. 6.93e+08. 